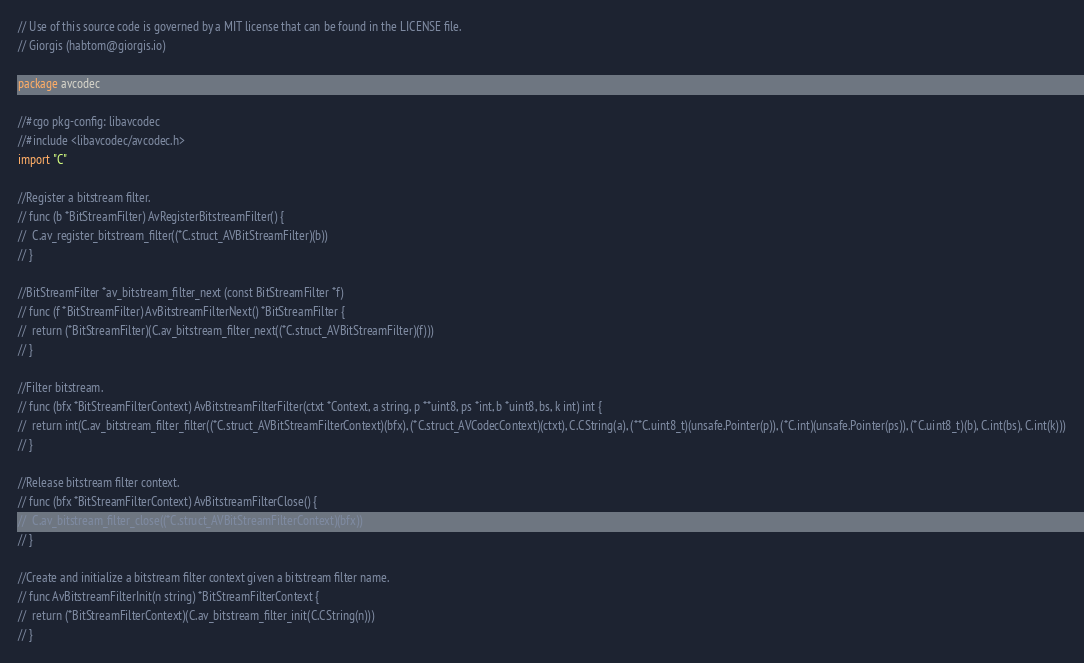Convert code to text. <code><loc_0><loc_0><loc_500><loc_500><_Go_>// Use of this source code is governed by a MIT license that can be found in the LICENSE file.
// Giorgis (habtom@giorgis.io)

package avcodec

//#cgo pkg-config: libavcodec
//#include <libavcodec/avcodec.h>
import "C"

//Register a bitstream filter.
// func (b *BitStreamFilter) AvRegisterBitstreamFilter() {
// 	C.av_register_bitstream_filter((*C.struct_AVBitStreamFilter)(b))
// }

//BitStreamFilter *av_bitstream_filter_next (const BitStreamFilter *f)
// func (f *BitStreamFilter) AvBitstreamFilterNext() *BitStreamFilter {
// 	return (*BitStreamFilter)(C.av_bitstream_filter_next((*C.struct_AVBitStreamFilter)(f)))
// }

//Filter bitstream.
// func (bfx *BitStreamFilterContext) AvBitstreamFilterFilter(ctxt *Context, a string, p **uint8, ps *int, b *uint8, bs, k int) int {
// 	return int(C.av_bitstream_filter_filter((*C.struct_AVBitStreamFilterContext)(bfx), (*C.struct_AVCodecContext)(ctxt), C.CString(a), (**C.uint8_t)(unsafe.Pointer(p)), (*C.int)(unsafe.Pointer(ps)), (*C.uint8_t)(b), C.int(bs), C.int(k)))
// }

//Release bitstream filter context.
// func (bfx *BitStreamFilterContext) AvBitstreamFilterClose() {
// 	C.av_bitstream_filter_close((*C.struct_AVBitStreamFilterContext)(bfx))
// }

//Create and initialize a bitstream filter context given a bitstream filter name.
// func AvBitstreamFilterInit(n string) *BitStreamFilterContext {
// 	return (*BitStreamFilterContext)(C.av_bitstream_filter_init(C.CString(n)))
// }
</code> 